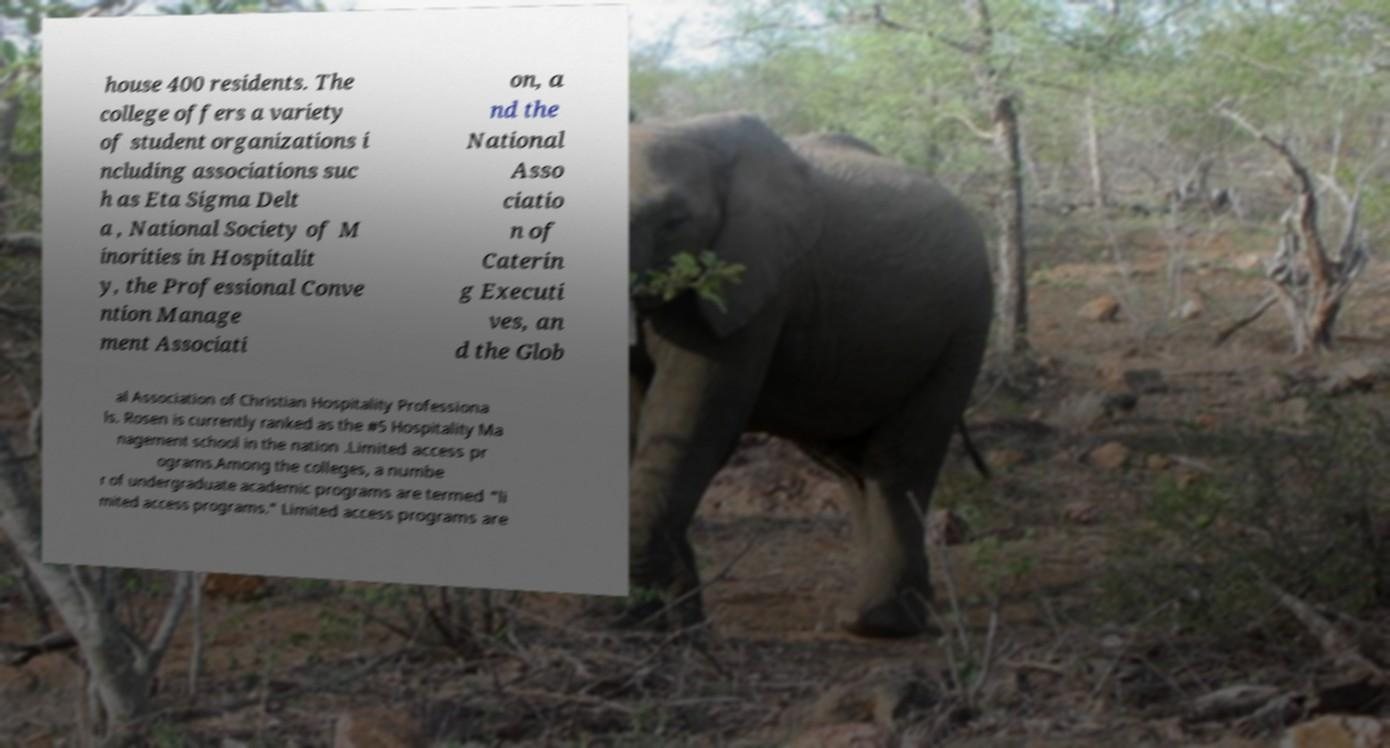Please identify and transcribe the text found in this image. house 400 residents. The college offers a variety of student organizations i ncluding associations suc h as Eta Sigma Delt a , National Society of M inorities in Hospitalit y, the Professional Conve ntion Manage ment Associati on, a nd the National Asso ciatio n of Caterin g Executi ves, an d the Glob al Association of Christian Hospitality Professiona ls. Rosen is currently ranked as the #5 Hospitality Ma nagement school in the nation .Limited access pr ograms.Among the colleges, a numbe r of undergraduate academic programs are termed "li mited access programs." Limited access programs are 